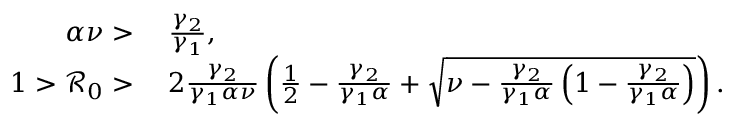Convert formula to latex. <formula><loc_0><loc_0><loc_500><loc_500>\begin{array} { r l } { \alpha \nu > } & { \, \frac { \gamma _ { 2 } } { \gamma _ { 1 } } , } \\ { 1 > \mathcal { R } _ { 0 } > } & { \, 2 \frac { \gamma _ { 2 } } { \gamma _ { 1 } \alpha \nu } \left ( \frac { 1 } { 2 } - \frac { \gamma _ { 2 } } { \gamma _ { 1 } \alpha } + \sqrt { \nu - \frac { \gamma _ { 2 } } { \gamma _ { 1 } \alpha } \left ( 1 - \frac { \gamma _ { 2 } } { \gamma _ { 1 } \alpha } \right ) } \right ) . } \end{array}</formula> 